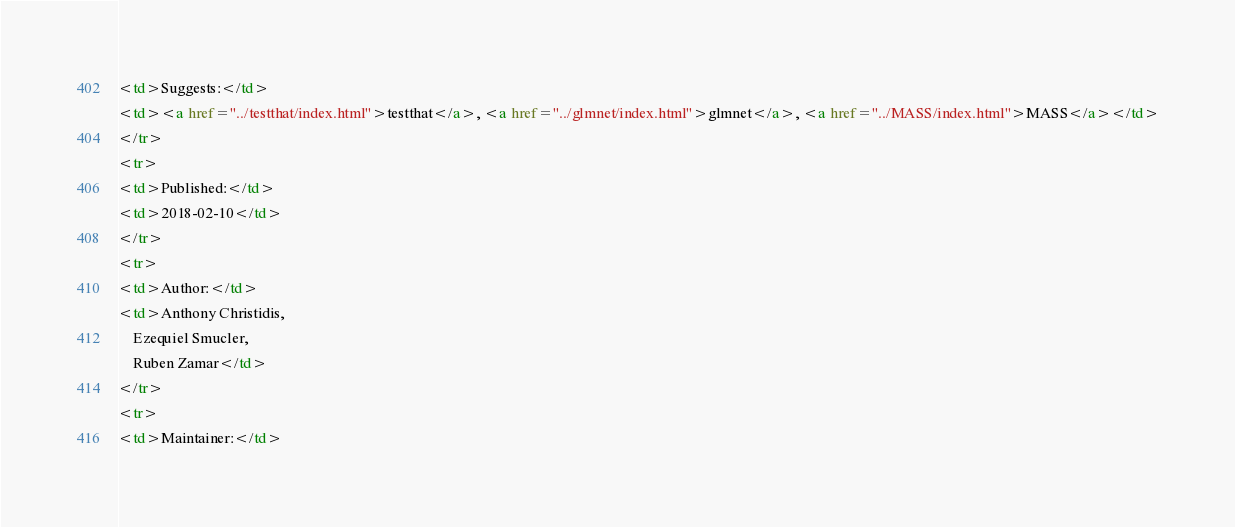<code> <loc_0><loc_0><loc_500><loc_500><_HTML_><td>Suggests:</td>
<td><a href="../testthat/index.html">testthat</a>, <a href="../glmnet/index.html">glmnet</a>, <a href="../MASS/index.html">MASS</a></td>
</tr>
<tr>
<td>Published:</td>
<td>2018-02-10</td>
</tr>
<tr>
<td>Author:</td>
<td>Anthony Christidis,
    Ezequiel Smucler,
    Ruben Zamar</td>
</tr>
<tr>
<td>Maintainer:</td></code> 